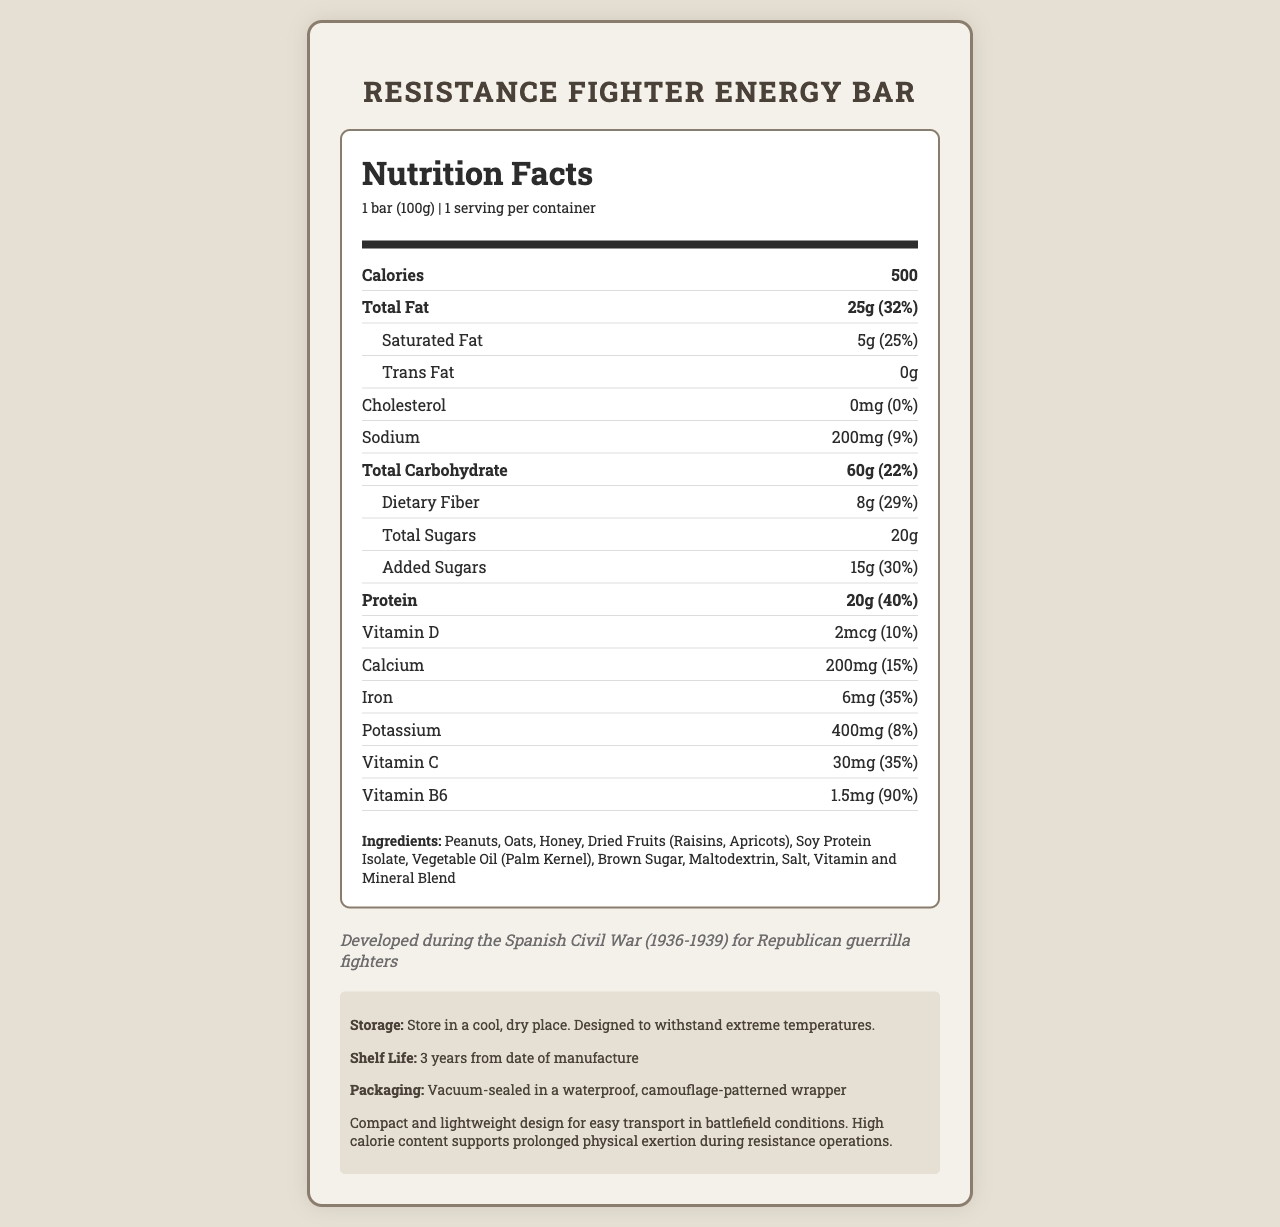what is the serving size of the Resistance Fighter Energy Bar? The serving size is clearly mentioned in the upper part of the nutrition label as "1 bar (100g)".
Answer: 1 bar (100g) how many calories are in one serving of the energy bar? The number of calories is listed in bold in the nutrition section as 500.
Answer: 500 what is the daily value percentage of dietary fiber in this energy bar? The daily value percentage of dietary fiber is given next to its amount under the carbohydrate section, which is 29%.
Answer: 29% List the three main macronutrients present and their amounts. This information is found under their respective sections in the nutrition label.
Answer: Total Fat: 25g, Total Carbohydrate: 60g, Protein: 20g which vitamins and minerals are included in the nutrition facts of this energy bar? These are listed in the nutrient rows toward the end of the nutrition label.
Answer: Vitamin D, Calcium, Iron, Potassium, Vitamin C, Vitamin B6 how much protein is in the energy bar, and what is its daily value percentage? The amount of protein and its daily value percentage (40%) are listed together in bold in the nutrition section.
Answer: 20g, 40% what percentage of the daily value does the added sugars in the energy bar make up? The percentage is listed next to the amount of added sugars in the sub-section under total carbohydrate.
Answer: 30% does the energy bar contain any trans fat? The document clearly mentions "0g" of trans fat, indicating there isn't any present.
Answer: No For how long can the energy bar be stored according to the shelf life? The shelf life is mentioned under the section titled "Storage" and is specified as "3 years from date of manufacture".
Answer: 3 years from date of manufacture When and for whom was the energy bar specially developed? This is specified in the historical context section of the document.
Answer: Developed during the Spanish Civil War (1936-1939) for Republican guerrilla fighters identify the main idea of the entire document. The document is organized into sections focusing on various aspects of the energy bar, including nutritional facts, ingredients, and historical context, painting a comprehensive picture of the product.
Answer: The document provides detailed nutritional information, ingredients, historical context, storage instructions, and additional information about the Resistance Fighter Energy Bar, a high-energy food product designed for use by Republican guerrilla fighters during the Spanish Civil War. how much vitamin B6 does the energy bar provide, and what is the daily value percentage? The amount of vitamin B6 and its corresponding daily value percentage are listed in the vitamin section of the nutrition label.
Answer: 1.5mg, 90% what is the primary ingredient listed in the energy bar? The list of ingredients begins with "Peanuts," making it the primary ingredient.
Answer: Peanuts which of the following statements is true about the energy bar's fat content? A. It contains 25g of total fat, with 32% daily value. B. It contains 5g of trans fat. C. It has a daily value of 0% for cholesterol. Statement A correctly describes the total fat content and daily value. Statement B is false because the energy bar contains 0g of trans fat, and Statement C concerns cholesterol, which is not about fat content.
Answer: A how many grams of saturated fat are in the energy bar? The saturated fat content is listed as 5g in the sub-section under total fat.
Answer: 5g True or False: The energy bar contains dried fruits such as raisins and apricots. The ingredients section lists "Dried Fruits (Raisins, Apricots)" as part of the composition.
Answer: True What is the color of the packaging of the energy bar? The document does not provide information on the color of the packaging; it only mentions that the wrapper has a camouflage pattern.
Answer: Cannot be determined 